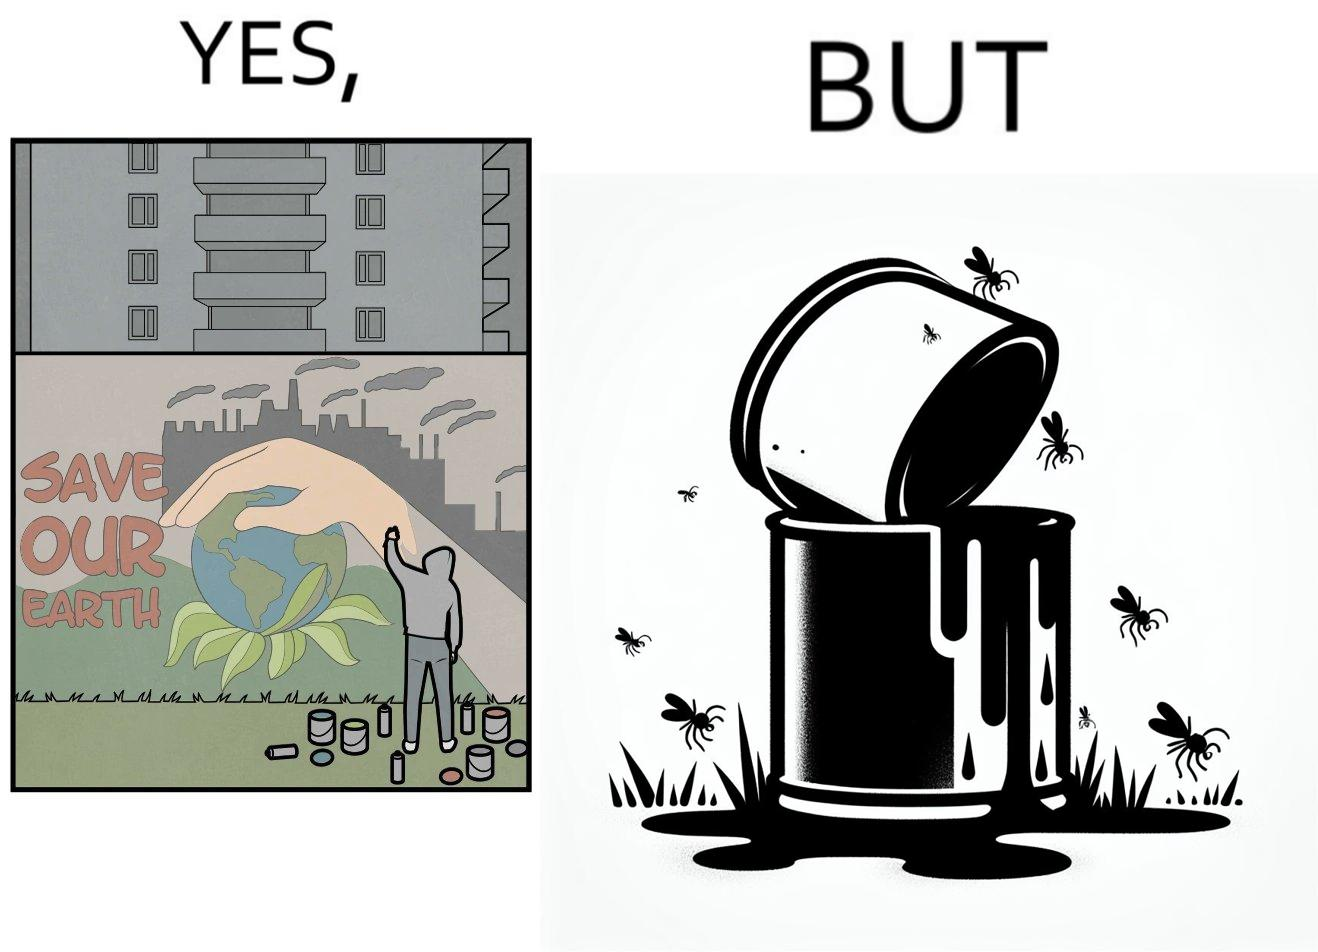Explain why this image is satirical. The image is ironical, as the cans of paint used to make graffiti on the theme "Save the Earth" seems to be destroying the Earth when it overflows on the grass, as it is harmful for the flora and fauna, as can be seen from the dying insects. 